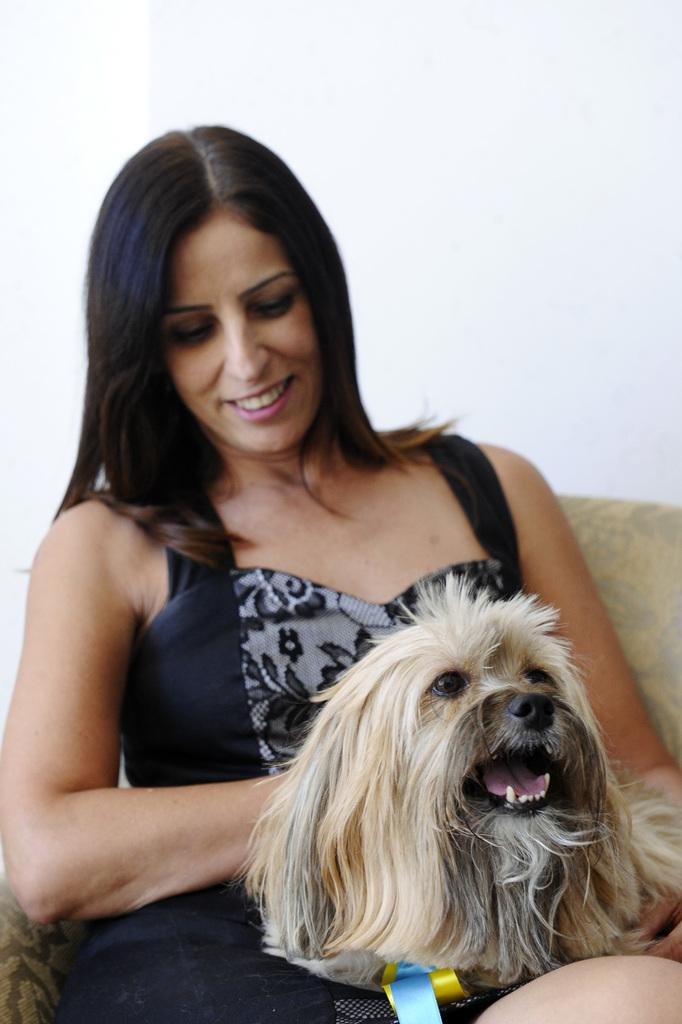Who is the main subject in the image? There is a woman in the image. What is the woman doing in the image? The woman is sitting. What is the woman holding in her hands? The woman is holding a dog in her hands. What can be seen in the background of the image? There is a wall visible in the image. What type of event is taking place in the image? There is no indication of an event taking place in the image. Can you see a turkey or a pail in the image? No, there is no turkey or pail present in the image. 